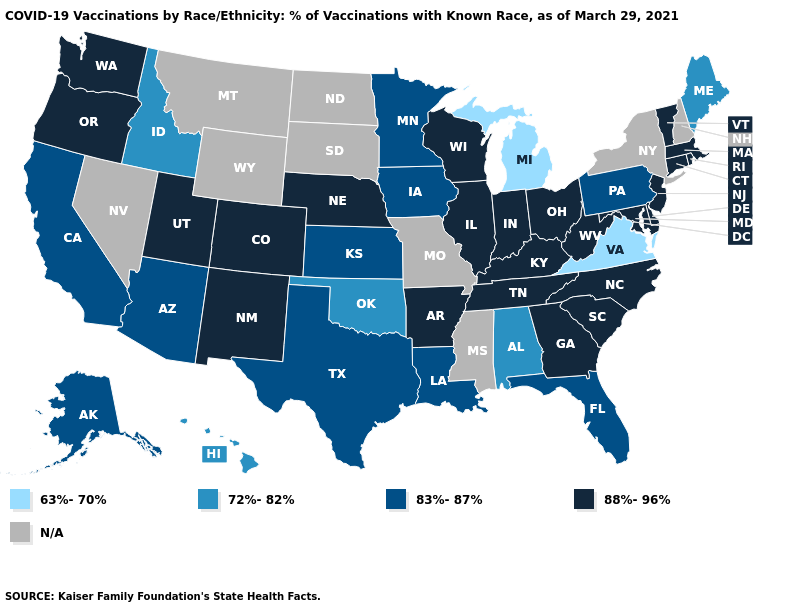Does Michigan have the lowest value in the USA?
Give a very brief answer. Yes. What is the value of Missouri?
Answer briefly. N/A. What is the value of Alabama?
Quick response, please. 72%-82%. Name the states that have a value in the range N/A?
Short answer required. Mississippi, Missouri, Montana, Nevada, New Hampshire, New York, North Dakota, South Dakota, Wyoming. Which states have the lowest value in the South?
Be succinct. Virginia. Is the legend a continuous bar?
Give a very brief answer. No. Does the first symbol in the legend represent the smallest category?
Write a very short answer. Yes. Name the states that have a value in the range 83%-87%?
Quick response, please. Alaska, Arizona, California, Florida, Iowa, Kansas, Louisiana, Minnesota, Pennsylvania, Texas. What is the value of Connecticut?
Quick response, please. 88%-96%. Name the states that have a value in the range N/A?
Concise answer only. Mississippi, Missouri, Montana, Nevada, New Hampshire, New York, North Dakota, South Dakota, Wyoming. What is the value of Florida?
Concise answer only. 83%-87%. Does the first symbol in the legend represent the smallest category?
Be succinct. Yes. Does South Carolina have the highest value in the USA?
Be succinct. Yes. 